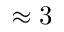<formula> <loc_0><loc_0><loc_500><loc_500>\approx 3</formula> 